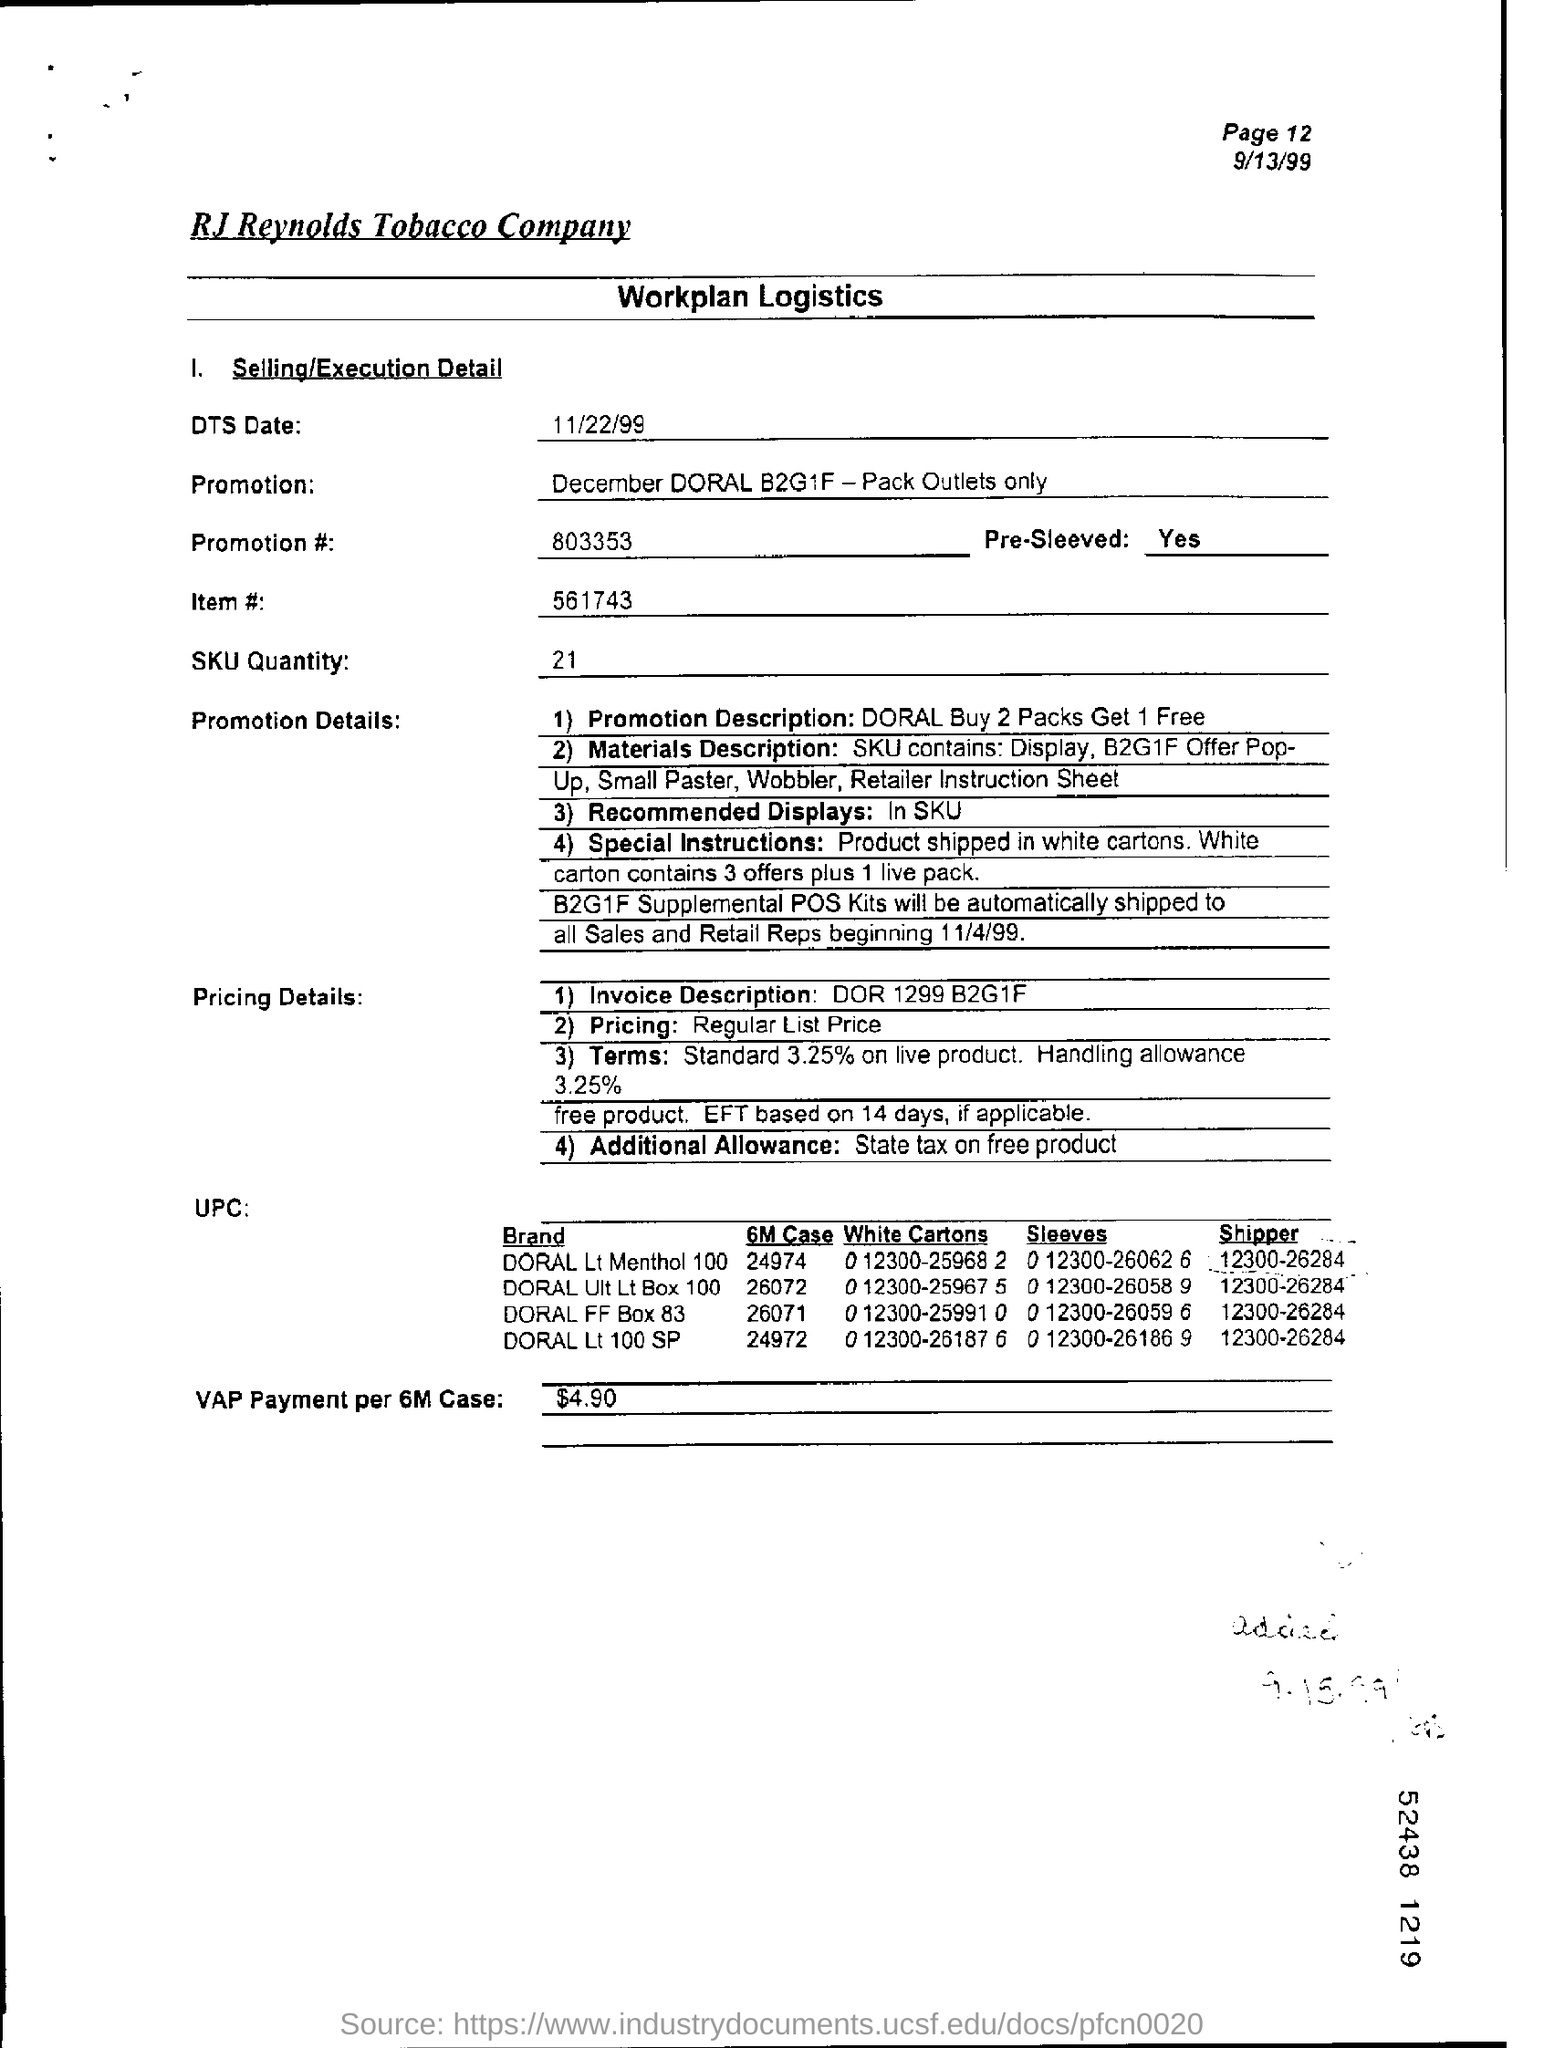What is the page number on this page
Offer a terse response. 12. What is the dts date on this page?
Make the answer very short. 11/22/99. What is the promotion number on the page?
Provide a succinct answer. 803353. What is the item number on the page?
Your response must be concise. 561743. What is the SKU quantity on the page?
Ensure brevity in your answer.  21. What is the VAP payment per 6M case?
Give a very brief answer. $4.90. 